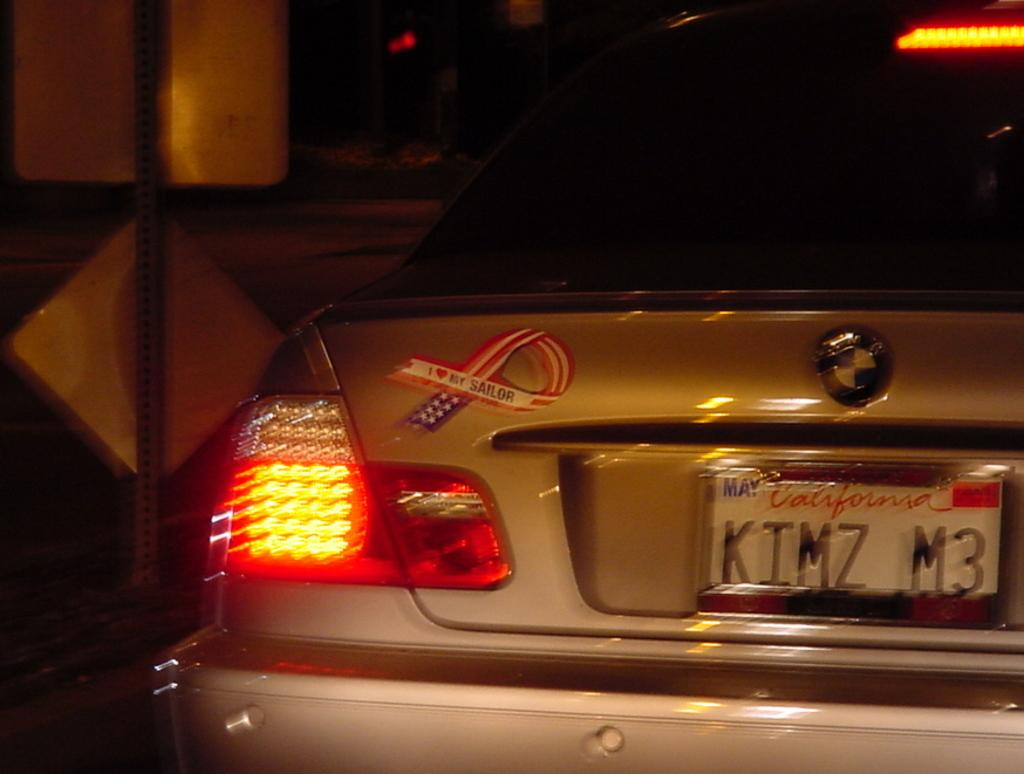Provide a one-sentence caption for the provided image. A silver BMW has a California plate that reads "KIMZ M3.". 